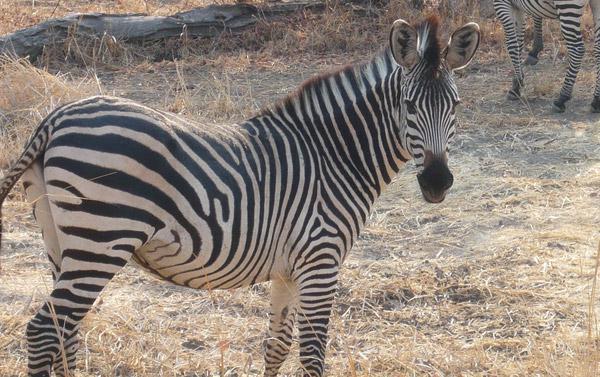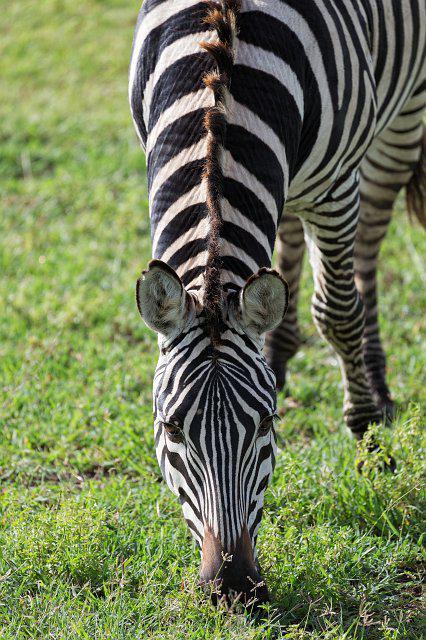The first image is the image on the left, the second image is the image on the right. Examine the images to the left and right. Is the description "The image on the right has two or fewer zebras." accurate? Answer yes or no. Yes. The first image is the image on the left, the second image is the image on the right. Considering the images on both sides, is "No image contains fewer that three zebras, and the left image includes rear-turned zebras in the foreground." valid? Answer yes or no. No. 